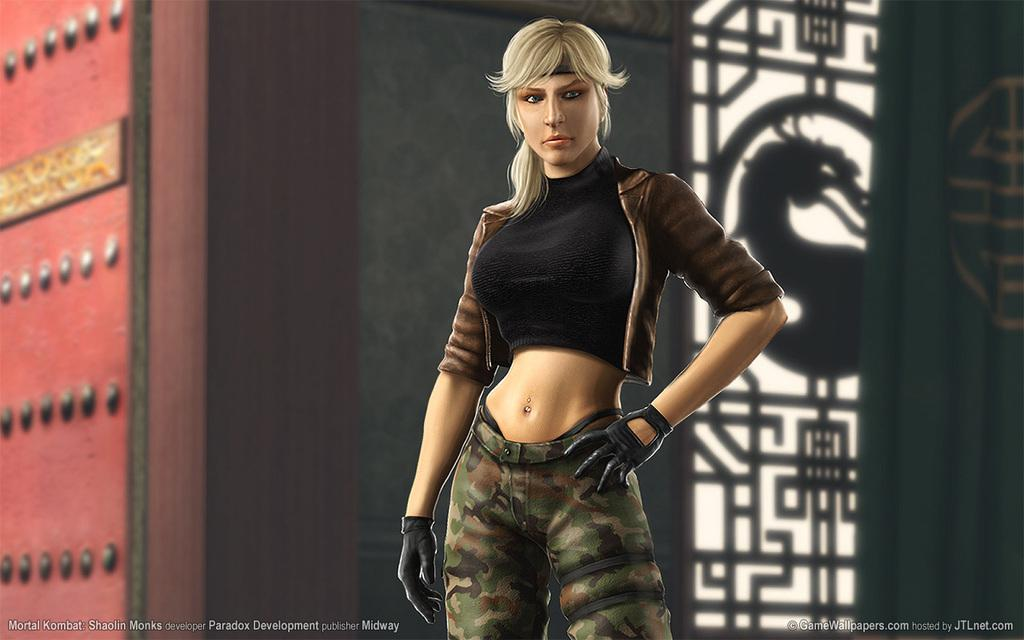What type of image is being described? The image is animated. Can you describe the characters or subjects in the image? There is a woman in the image. What else can be seen in the image besides the woman? There are objects in the image. Are there any visible markings or logos in the image? Yes, there are watermarks at the bottom of the image. How many oranges are being used by the woman in the image? There are no oranges present in the image. What is the front of the image showing? The provided facts do not mention a "front" of the image, as it is an animated image and not a physical object with a front and back. 